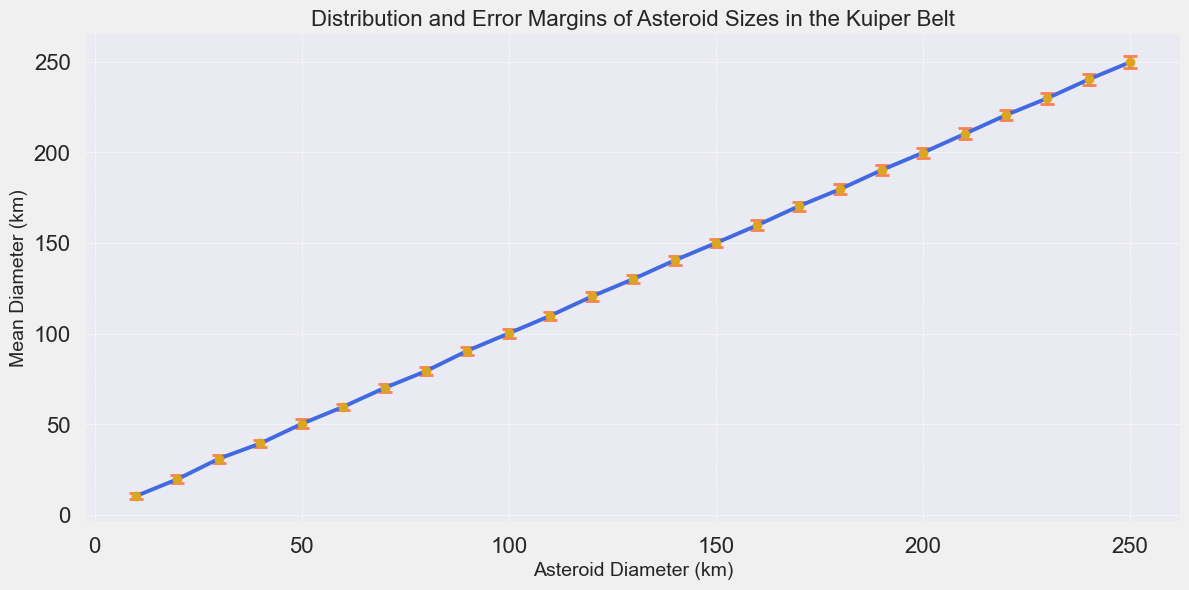What is the asteroid diameter with the largest error margin? The error margins are shown as vertical lines on the data points. The asteroid with the largest error margin has an error bar extending beyond 3 kilometers in both directions. This occurs for the asteroid with a diameter of 230 kilometers where the error margin is 3.1 kilometers.
Answer: 230 km Which asteroid diameter has the smallest error margin? The smallest error margin can be identified by the shortest vertical error bar. By comparing all error bars, the asteroid with a diameter of 60 kilometers has the smallest error margin of 1.8 kilometers.
Answer: 60 km How does the error margin of a 100-kilometer asteroid compare to that of a 200-kilometer asteroid? The error margin of the 100-kilometer asteroid is 2.4 kilometers, while the 200-kilometer asteroid has an error margin of 2.8 kilometers. Thus, the error margin for the 200-kilometer asteroid is larger by 0.4 kilometers.
Answer: The 200-kilometer asteroid's error margin is larger by 0.4 km What is the average error margin across all asteroid sizes? To find the average error margin, add up all the error margins and divide by the number of data points. \( \frac{1.5 + 2.1 + 2.2 + 1.9 + 2.5 + 1.8 + 2.0 + 2.3 + 2.1 + 2.4 + 2.2 + 2.5 + 2.3 + 2.6 + 2.4 + 2.7 + 2.5 + 2.9 + 2.6 + 2.8 + 3.0 + 2.7 + 3.1 + 2.9 + 3.2}{25} \approx 2.474 \) kilometers.
Answer: 2.474 km Which asteroid diameter has the mean diameter close to its true diameter with the smallest error margin? Finding the data point where the mean diameter closely matches the true diameter and has a minimal error bar involves visually identifying the shortest error bar where the mean diameter is very close to the actual diameter. The asteroid with a 10-kilometer diameter has a mean very close to 10.5 kilometers, not the smallest error margin. Next is 20-kilometer but with 19.8, still not smallest. Check all data points, and confirm its the 60 km diameter asteroid.
Answer: 60 km 